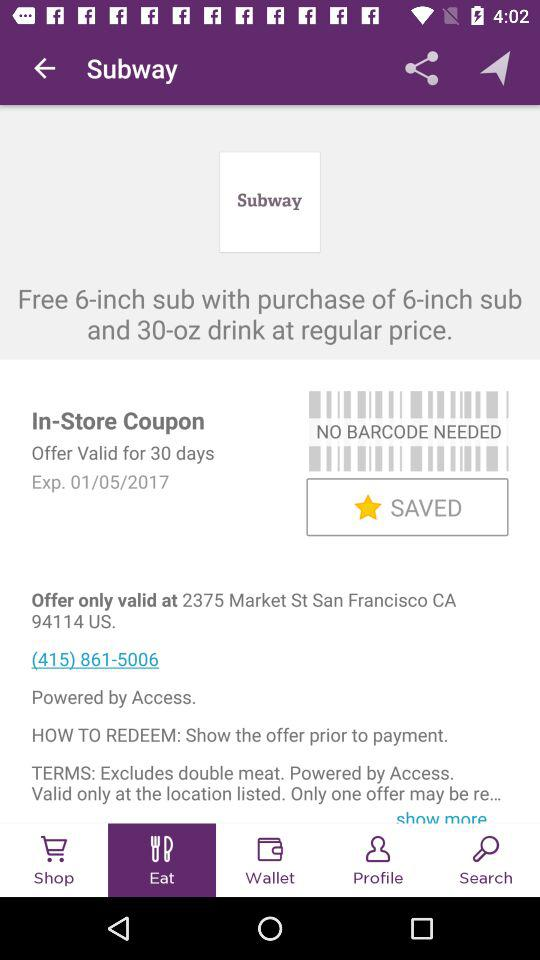How many items do I need to purchase to get the free 6-inch sub?
Answer the question using a single word or phrase. 2 